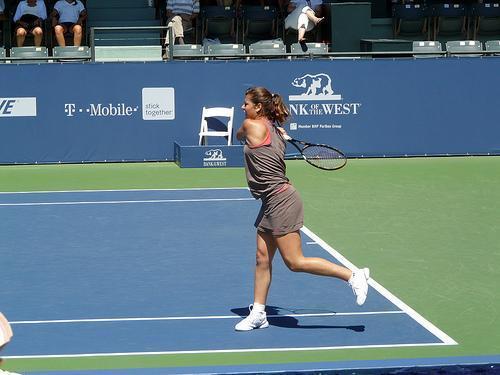How many women holding a racket?
Give a very brief answer. 1. 